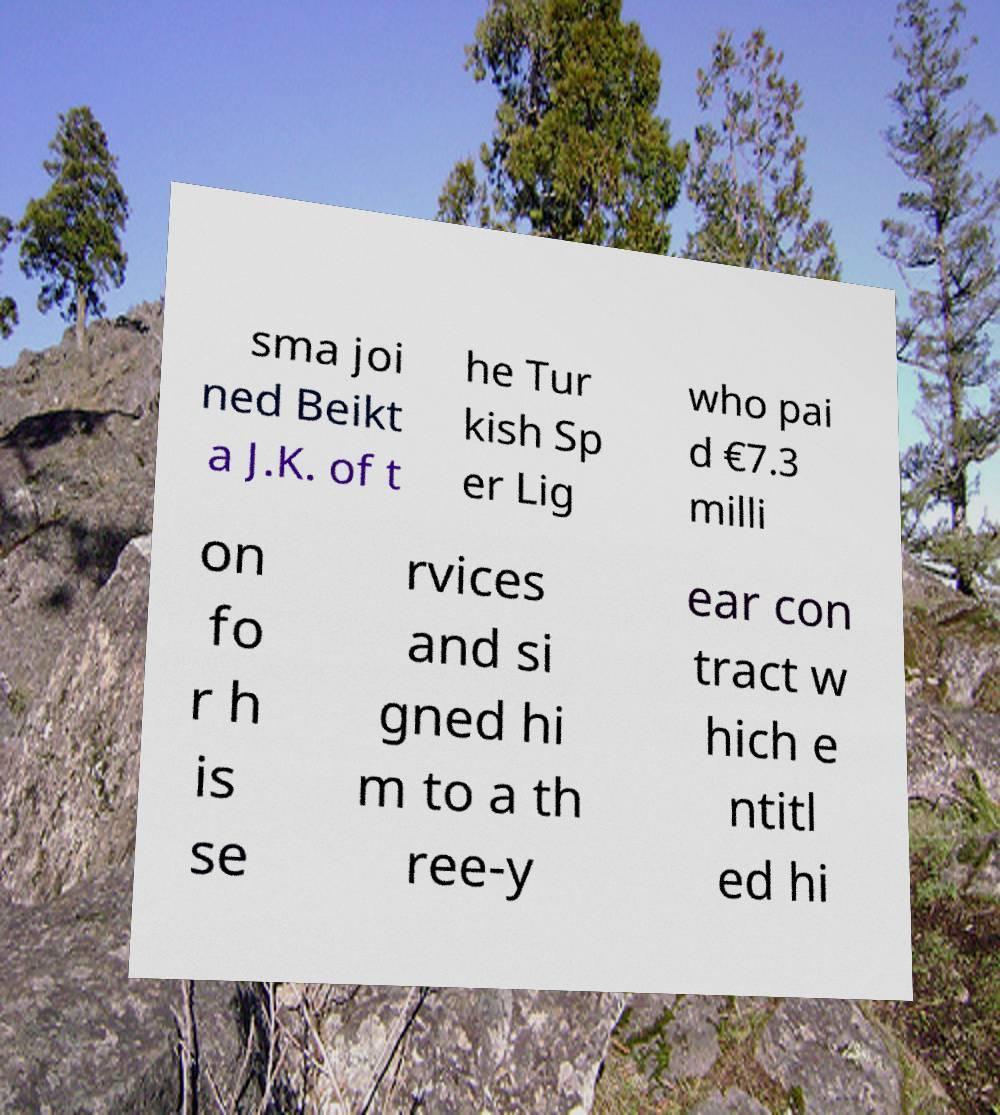Can you read and provide the text displayed in the image?This photo seems to have some interesting text. Can you extract and type it out for me? sma joi ned Beikt a J.K. of t he Tur kish Sp er Lig who pai d €7.3 milli on fo r h is se rvices and si gned hi m to a th ree-y ear con tract w hich e ntitl ed hi 